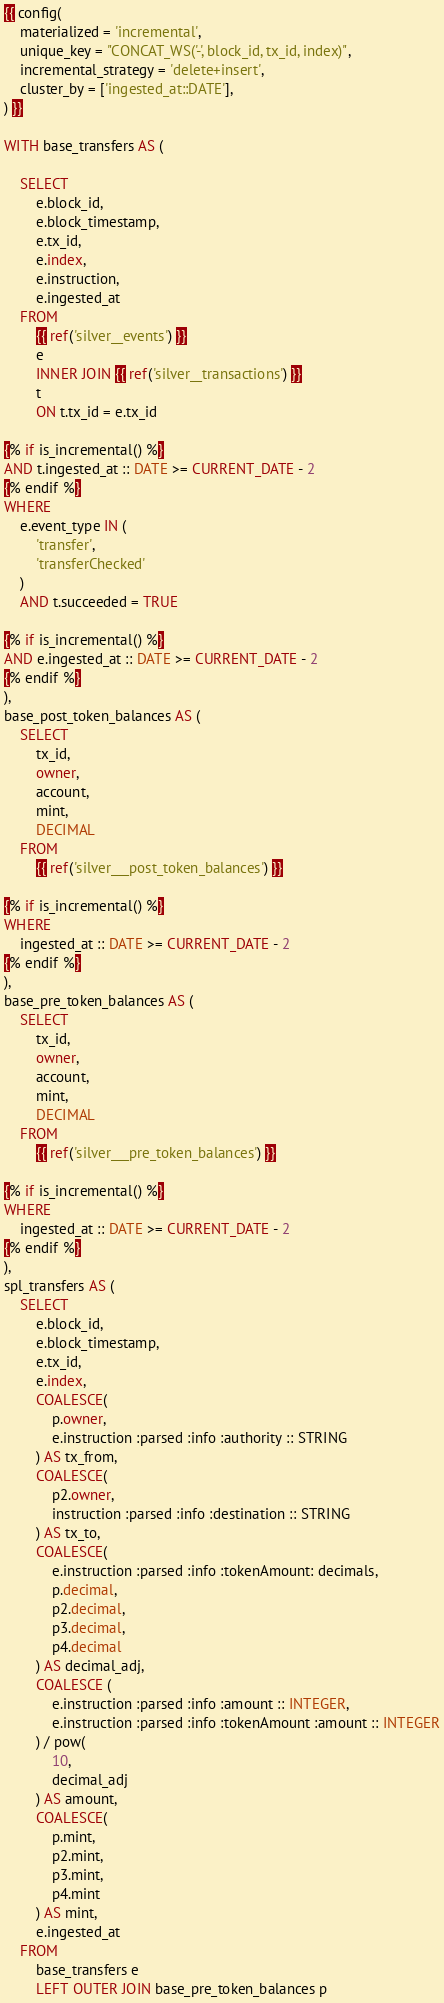Convert code to text. <code><loc_0><loc_0><loc_500><loc_500><_SQL_>{{ config(
    materialized = 'incremental',
    unique_key = "CONCAT_WS('-', block_id, tx_id, index)",
    incremental_strategy = 'delete+insert',
    cluster_by = ['ingested_at::DATE'],
) }}

WITH base_transfers AS (

    SELECT
        e.block_id,
        e.block_timestamp,
        e.tx_id,
        e.index,
        e.instruction,
        e.ingested_at
    FROM
        {{ ref('silver__events') }}
        e
        INNER JOIN {{ ref('silver__transactions') }}
        t
        ON t.tx_id = e.tx_id

{% if is_incremental() %}
AND t.ingested_at :: DATE >= CURRENT_DATE - 2
{% endif %}
WHERE
    e.event_type IN (
        'transfer',
        'transferChecked'
    )
    AND t.succeeded = TRUE

{% if is_incremental() %}
AND e.ingested_at :: DATE >= CURRENT_DATE - 2
{% endif %}
),
base_post_token_balances AS (
    SELECT
        tx_id,
        owner,
        account,
        mint,
        DECIMAL
    FROM
        {{ ref('silver___post_token_balances') }}

{% if is_incremental() %}
WHERE
    ingested_at :: DATE >= CURRENT_DATE - 2
{% endif %}
),
base_pre_token_balances AS (
    SELECT
        tx_id,
        owner,
        account,
        mint,
        DECIMAL
    FROM
        {{ ref('silver___pre_token_balances') }}

{% if is_incremental() %}
WHERE
    ingested_at :: DATE >= CURRENT_DATE - 2
{% endif %}
),
spl_transfers AS (
    SELECT
        e.block_id,
        e.block_timestamp,
        e.tx_id,
        e.index,
        COALESCE(
            p.owner,
            e.instruction :parsed :info :authority :: STRING
        ) AS tx_from,
        COALESCE(
            p2.owner,
            instruction :parsed :info :destination :: STRING
        ) AS tx_to,
        COALESCE(
            e.instruction :parsed :info :tokenAmount: decimals,
            p.decimal,
            p2.decimal,
            p3.decimal,
            p4.decimal
        ) AS decimal_adj,
        COALESCE (
            e.instruction :parsed :info :amount :: INTEGER,
            e.instruction :parsed :info :tokenAmount :amount :: INTEGER
        ) / pow(
            10,
            decimal_adj
        ) AS amount,
        COALESCE(
            p.mint,
            p2.mint,
            p3.mint,
            p4.mint
        ) AS mint,
        e.ingested_at
    FROM
        base_transfers e
        LEFT OUTER JOIN base_pre_token_balances p</code> 